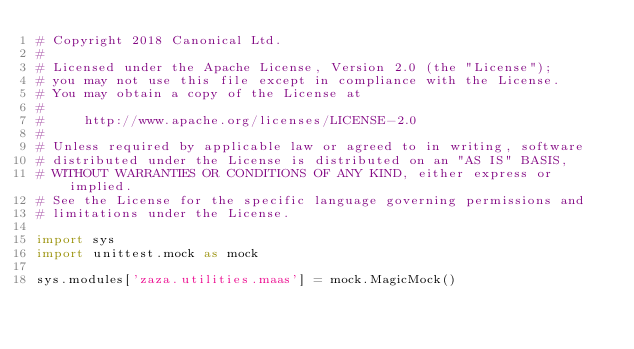Convert code to text. <code><loc_0><loc_0><loc_500><loc_500><_Python_># Copyright 2018 Canonical Ltd.
#
# Licensed under the Apache License, Version 2.0 (the "License");
# you may not use this file except in compliance with the License.
# You may obtain a copy of the License at
#
#     http://www.apache.org/licenses/LICENSE-2.0
#
# Unless required by applicable law or agreed to in writing, software
# distributed under the License is distributed on an "AS IS" BASIS,
# WITHOUT WARRANTIES OR CONDITIONS OF ANY KIND, either express or implied.
# See the License for the specific language governing permissions and
# limitations under the License.

import sys
import unittest.mock as mock

sys.modules['zaza.utilities.maas'] = mock.MagicMock()
</code> 